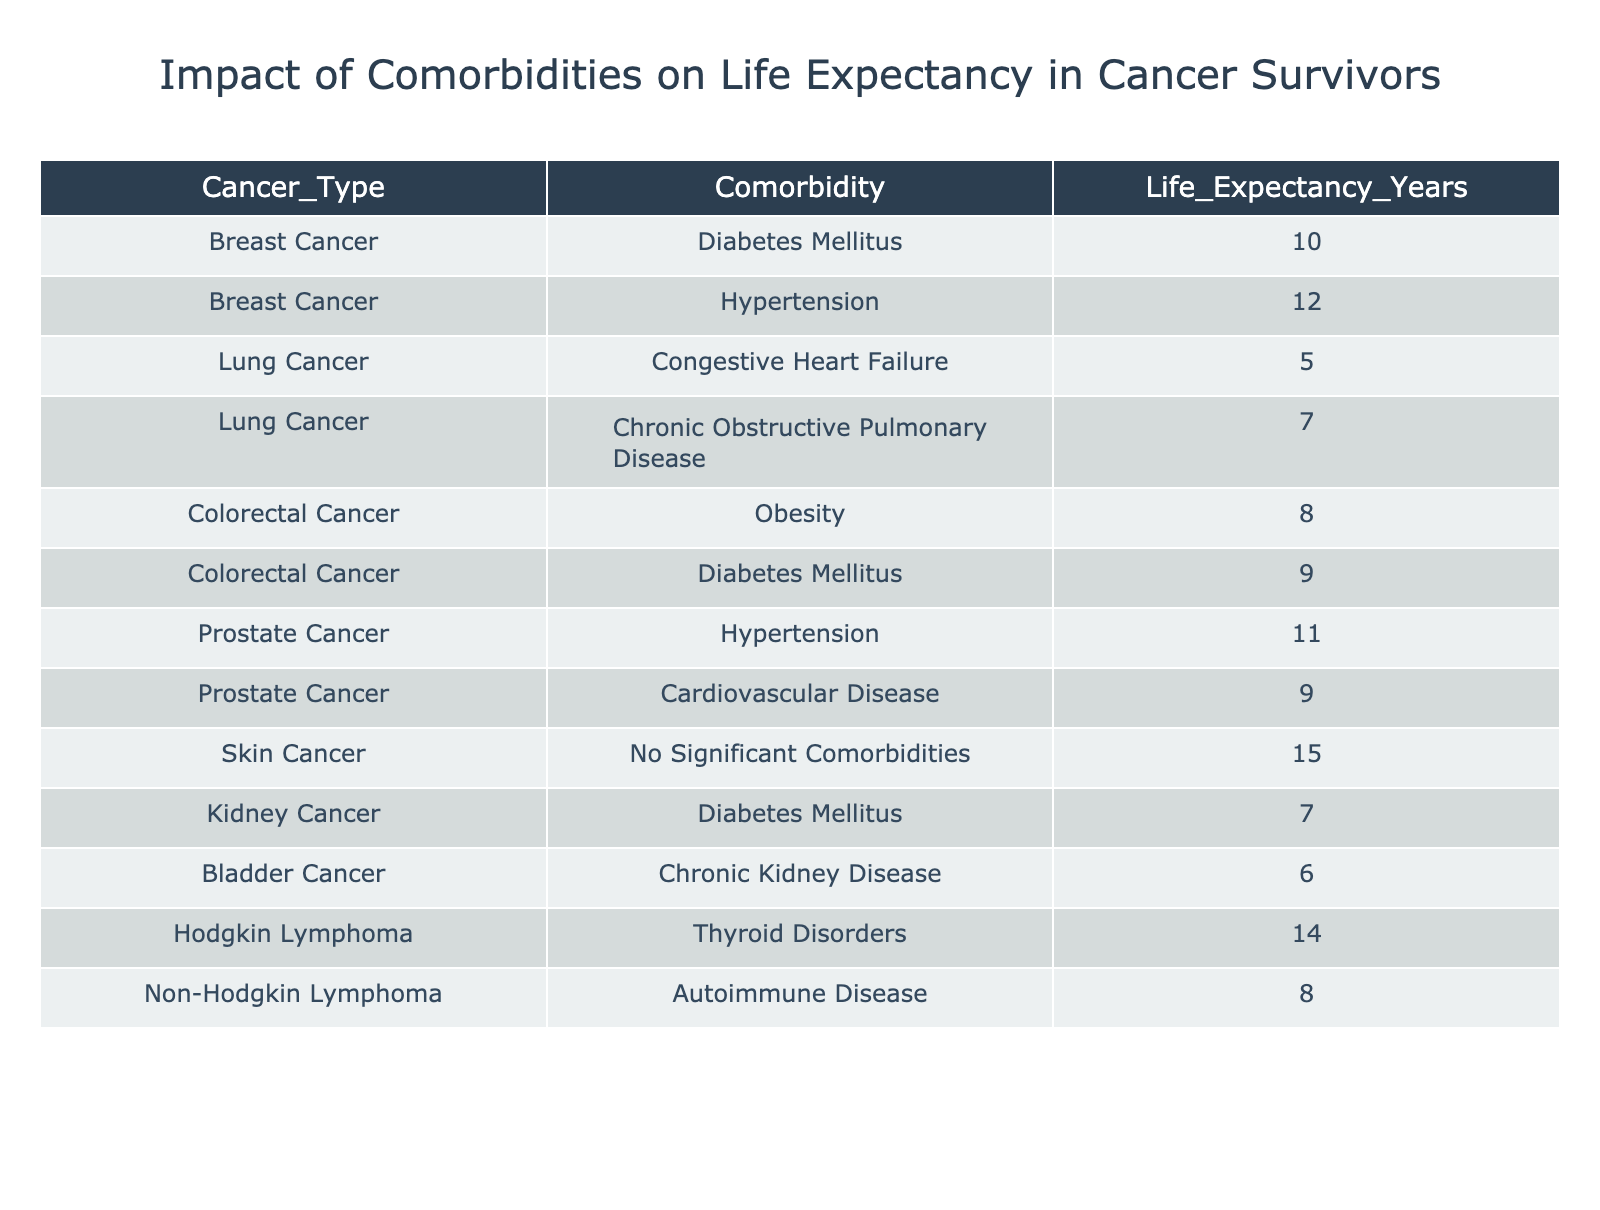What is the life expectancy for breast cancer patients with diabetes mellitus? According to the table, the life expectancy for breast cancer patients with diabetes mellitus is listed as 10 years.
Answer: 10 years Which cancer type with comorbidity has the lowest life expectancy? The table shows that lung cancer patients with congestive heart failure have the lowest life expectancy of 5 years.
Answer: Lung cancer with congestive heart failure How many years of life expectancy do colorectal cancer patients with obesity have compared to those with diabetes mellitus? From the table, colorectal cancer patients with obesity have a life expectancy of 8 years, whereas those with diabetes mellitus have a life expectancy of 9 years. The difference in life expectancy is 9 - 8 = 1 year.
Answer: 1 year Is it true that prostate cancer patients with cardiovascular disease have a higher life expectancy than those with hypertension? The life expectancy for prostate cancer patients with cardiovascular disease is 9 years, while for those with hypertension it is 11 years. Therefore, the statement is false as 11 years is greater than 9 years.
Answer: No What is the average life expectancy of skin cancer patients and Hodgkin lymphoma patients combined? The life expectancy for skin cancer patients with no significant comorbidities is 15 years, and for Hodgkin lymphoma patients with thyroid disorders, it is 14 years. To find the average, add them together (15 + 14 = 29) and divide by 2, resulting in an average of 29 / 2 = 14.5 years.
Answer: 14.5 years How does the life expectancy of kidney cancer patients with diabetes mellitus compare to that of bladder cancer patients with chronic kidney disease? The life expectancy for kidney cancer patients with diabetes mellitus is 7 years, and for bladder cancer patients with chronic kidney disease, it is 6 years. The kidney cancer patients have a higher life expectancy by 1 year (7 - 6 = 1 year).
Answer: 1 year What is the total life expectancy of all lung cancer patients based on their comorbidities listed? The life expectancies of lung cancer patients based on their comorbidities are 5 years (congestive heart failure) and 7 years (chronic obstructive pulmonary disease). Summing these gives 5 + 7 = 12 years.
Answer: 12 years Do all cancer types listed in the table have patients with significant comorbidities? The table indicates that skin cancer patients are noted to have "No Significant Comorbidities," which means not all cancer types listed have patients with significant comorbidities. Therefore, the statement is false.
Answer: No 